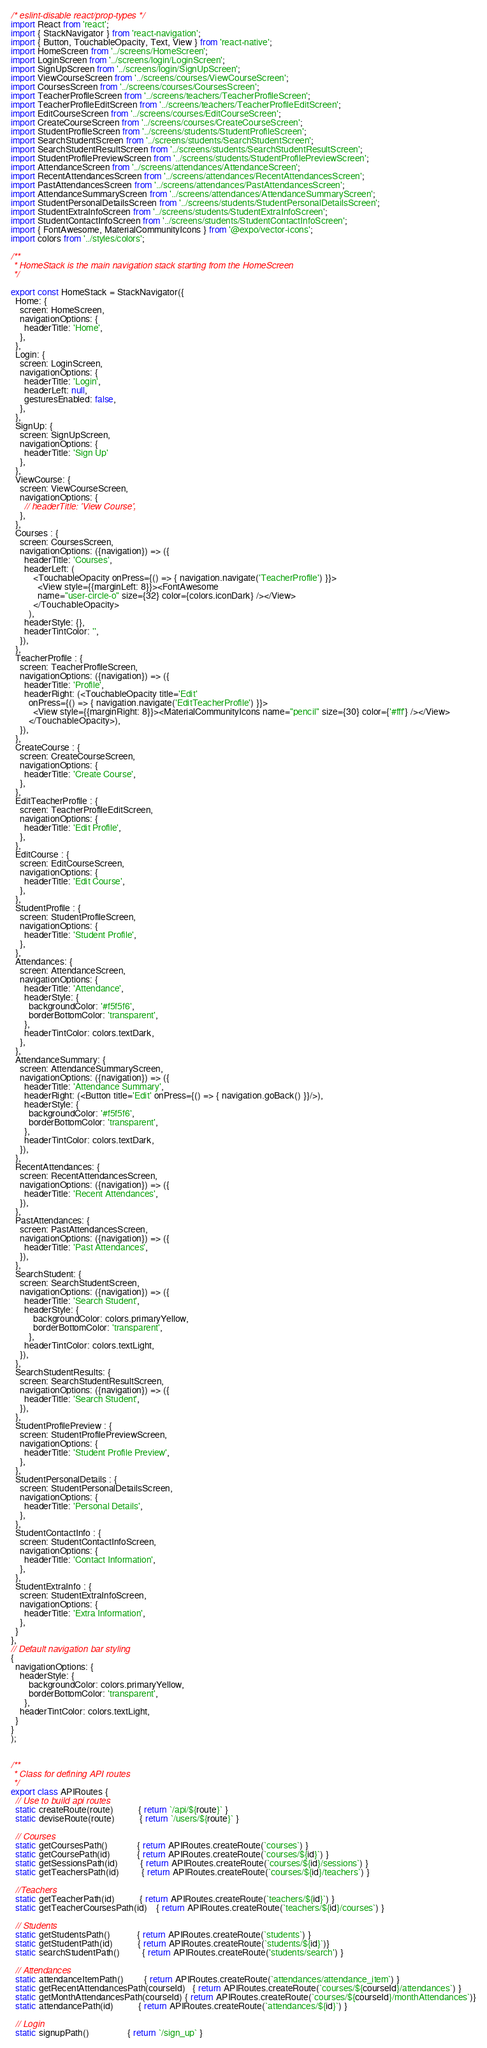Convert code to text. <code><loc_0><loc_0><loc_500><loc_500><_JavaScript_>/* eslint-disable react/prop-types */
import React from 'react';
import { StackNavigator } from 'react-navigation';
import { Button, TouchableOpacity, Text, View } from 'react-native';
import HomeScreen from '../screens/HomeScreen';
import LoginScreen from '../screens/login/LoginScreen';
import SignUpScreen from '../screens/login/SignUpScreen';
import ViewCourseScreen from '../screens/courses/ViewCourseScreen';
import CoursesScreen from '../screens/courses/CoursesScreen';
import TeacherProfileScreen from '../screens/teachers/TeacherProfileScreen';
import TeacherProfileEditScreen from '../screens/teachers/TeacherProfileEditScreen';
import EditCourseScreen from '../screens/courses/EditCourseScreen';
import CreateCourseScreen from '../screens/courses/CreateCourseScreen';
import StudentProfileScreen from '../screens/students/StudentProfileScreen';
import SearchStudentScreen from '../screens/students/SearchStudentScreen';
import SearchStudentResultScreen from '../screens/students/SearchStudentResultScreen';
import StudentProfilePreviewScreen from '../screens/students/StudentProfilePreviewScreen';
import AttendanceScreen from '../screens/attendances/AttendanceScreen';
import RecentAttendancesScreen from '../screens/attendances/RecentAttendancesScreen';
import PastAttendancesScreen from '../screens/attendances/PastAttendancesScreen';
import AttendanceSummaryScreen from '../screens/attendances/AttendanceSummaryScreen';
import StudentPersonalDetailsScreen from '../screens/students/StudentPersonalDetailsScreen';
import StudentExtraInfoScreen from '../screens/students/StudentExtraInfoScreen';
import StudentContactInfoScreen from '../screens/students/StudentContactInfoScreen';
import { FontAwesome, MaterialCommunityIcons } from '@expo/vector-icons';
import colors from '../styles/colors';

/**
 * HomeStack is the main navigation stack starting from the HomeScreen
 */

export const HomeStack = StackNavigator({
  Home: {
    screen: HomeScreen,
    navigationOptions: {
      headerTitle: 'Home',
    },
  },
  Login: {
    screen: LoginScreen,
    navigationOptions: {
      headerTitle: 'Login',
      headerLeft: null,
      gesturesEnabled: false,
    },
  },
  SignUp: {
    screen: SignUpScreen,
    navigationOptions: {
      headerTitle: 'Sign Up'
    },
  },
  ViewCourse: {
    screen: ViewCourseScreen,
    navigationOptions: {
      // headerTitle: 'View Course',
    },
  },
  Courses : {
    screen: CoursesScreen,
    navigationOptions: ({navigation}) => ({
      headerTitle: 'Courses',
      headerLeft: (
          <TouchableOpacity onPress={() => { navigation.navigate('TeacherProfile') }}>
            <View style={{marginLeft: 8}}><FontAwesome 
            name="user-circle-o" size={32} color={colors.iconDark} /></View>
          </TouchableOpacity>
        ),
      headerStyle: {},
      headerTintColor: '',
    }),
  },
  TeacherProfile : {
    screen: TeacherProfileScreen,
    navigationOptions: ({navigation}) => ({
      headerTitle: 'Profile',
      headerRight: (<TouchableOpacity title='Edit' 
        onPress={() => { navigation.navigate('EditTeacherProfile') }}>
          <View style={{marginRight: 8}}><MaterialCommunityIcons name="pencil" size={30} color={'#fff'} /></View>
        </TouchableOpacity>),
    }),
  },
  CreateCourse : {
    screen: CreateCourseScreen,
    navigationOptions: {
      headerTitle: 'Create Course',
    },
  },
  EditTeacherProfile : {
    screen: TeacherProfileEditScreen,
    navigationOptions: {
      headerTitle: 'Edit Profile',
    },
  },
  EditCourse : {
    screen: EditCourseScreen,
    navigationOptions: {
      headerTitle: 'Edit Course',
    },
  },
  StudentProfile : {
    screen: StudentProfileScreen,
    navigationOptions: {
      headerTitle: 'Student Profile',
    },
  },
  Attendances: {
    screen: AttendanceScreen,
    navigationOptions: {
      headerTitle: 'Attendance',
      headerStyle: {
        backgroundColor: '#f5f5f6',
        borderBottomColor: 'transparent',
      },
      headerTintColor: colors.textDark,
    },
  },
  AttendanceSummary: {
    screen: AttendanceSummaryScreen,
    navigationOptions: ({navigation}) => ({
      headerTitle: 'Attendance Summary',
      headerRight: (<Button title='Edit' onPress={() => { navigation.goBack() }}/>),
      headerStyle: {
        backgroundColor: '#f5f5f6',
        borderBottomColor: 'transparent',
      },
      headerTintColor: colors.textDark,
    }),
  },
  RecentAttendances: {
    screen: RecentAttendancesScreen,
    navigationOptions: ({navigation}) => ({
      headerTitle: 'Recent Attendances',
    }),
  },
  PastAttendances: {
    screen: PastAttendancesScreen,
    navigationOptions: ({navigation}) => ({
      headerTitle: 'Past Attendances',
    }),
  },
  SearchStudent: {
    screen: SearchStudentScreen,
    navigationOptions: ({navigation}) => ({
      headerTitle: 'Search Student',
      headerStyle: {
          backgroundColor: colors.primaryYellow,
          borderBottomColor: 'transparent',
        }, 
      headerTintColor: colors.textLight, 
    }),
  },
  SearchStudentResults: {
    screen: SearchStudentResultScreen,
    navigationOptions: ({navigation}) => ({
      headerTitle: 'Search Student',
    }),
  },
  StudentProfilePreview : {
    screen: StudentProfilePreviewScreen,
    navigationOptions: {
      headerTitle: 'Student Profile Preview',
    },
  },
  StudentPersonalDetails : {
    screen: StudentPersonalDetailsScreen,
    navigationOptions: {
      headerTitle: 'Personal Details',
    },
  },
  StudentContactInfo : {
    screen: StudentContactInfoScreen,
    navigationOptions: {
      headerTitle: 'Contact Information',
    },
  },
  StudentExtraInfo : {
    screen: StudentExtraInfoScreen,
    navigationOptions: {
      headerTitle: 'Extra Information',
    },
  }
},
// Default navigation bar styling
{
  navigationOptions: {
    headerStyle: {
        backgroundColor: colors.primaryYellow,
        borderBottomColor: 'transparent',
      }, 
    headerTintColor: colors.textLight, 
  }
}
);


/**
 * Class for defining API routes
 */
export class APIRoutes {
  // Use to build api routes
  static createRoute(route)           { return `/api/${route}` }
  static deviseRoute(route)           { return `/users/${route}` }

  // Courses
  static getCoursesPath()             { return APIRoutes.createRoute(`courses`) }
  static getCoursePath(id)            { return APIRoutes.createRoute(`courses/${id}`) }
  static getSessionsPath(id)          { return APIRoutes.createRoute(`courses/${id}/sessions`) }
  static getTeachersPath(id)          { return APIRoutes.createRoute(`courses/${id}/teachers`) }

  //Teachers
  static getTeacherPath(id)           { return APIRoutes.createRoute(`teachers/${id}`) }
  static getTeacherCoursesPath(id)    { return APIRoutes.createRoute(`teachers/${id}/courses`) }

  // Students
  static getStudentsPath()            { return APIRoutes.createRoute(`students`) }
  static getStudentPath(id)           { return APIRoutes.createRoute(`students/${id}`)}
  static searchStudentPath()          { return APIRoutes.createRoute('students/search') }

  // Attendances
  static attendanceItemPath()         { return APIRoutes.createRoute(`attendances/attendance_item`) }
  static getRecentAttendancesPath(courseId)   { return APIRoutes.createRoute(`courses/${courseId}/attendances`) }
  static getMonthAttendancesPath(courseId) { return APIRoutes.createRoute(`courses/${courseId}/monthAttendances`)}
  static attendancePath(id)           { return APIRoutes.createRoute(`attendances/${id}`) }

  // Login
  static signupPath()                 { return `/sign_up` }</code> 